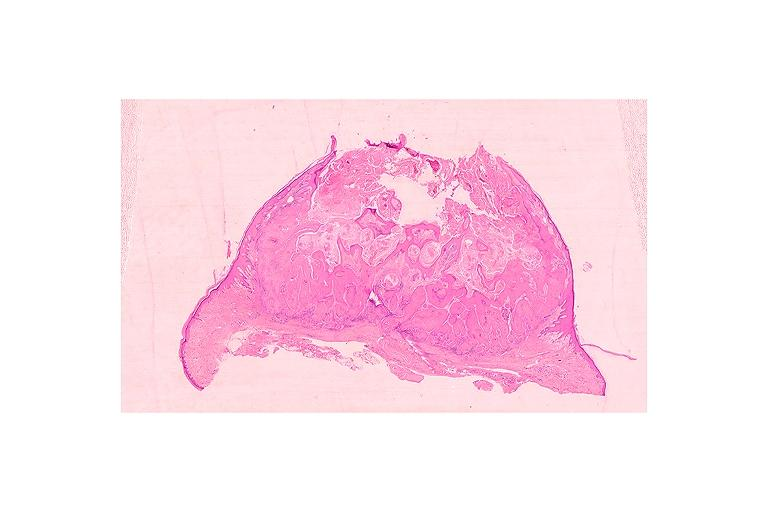does malignant adenoma show keratoacanthoma?
Answer the question using a single word or phrase. No 